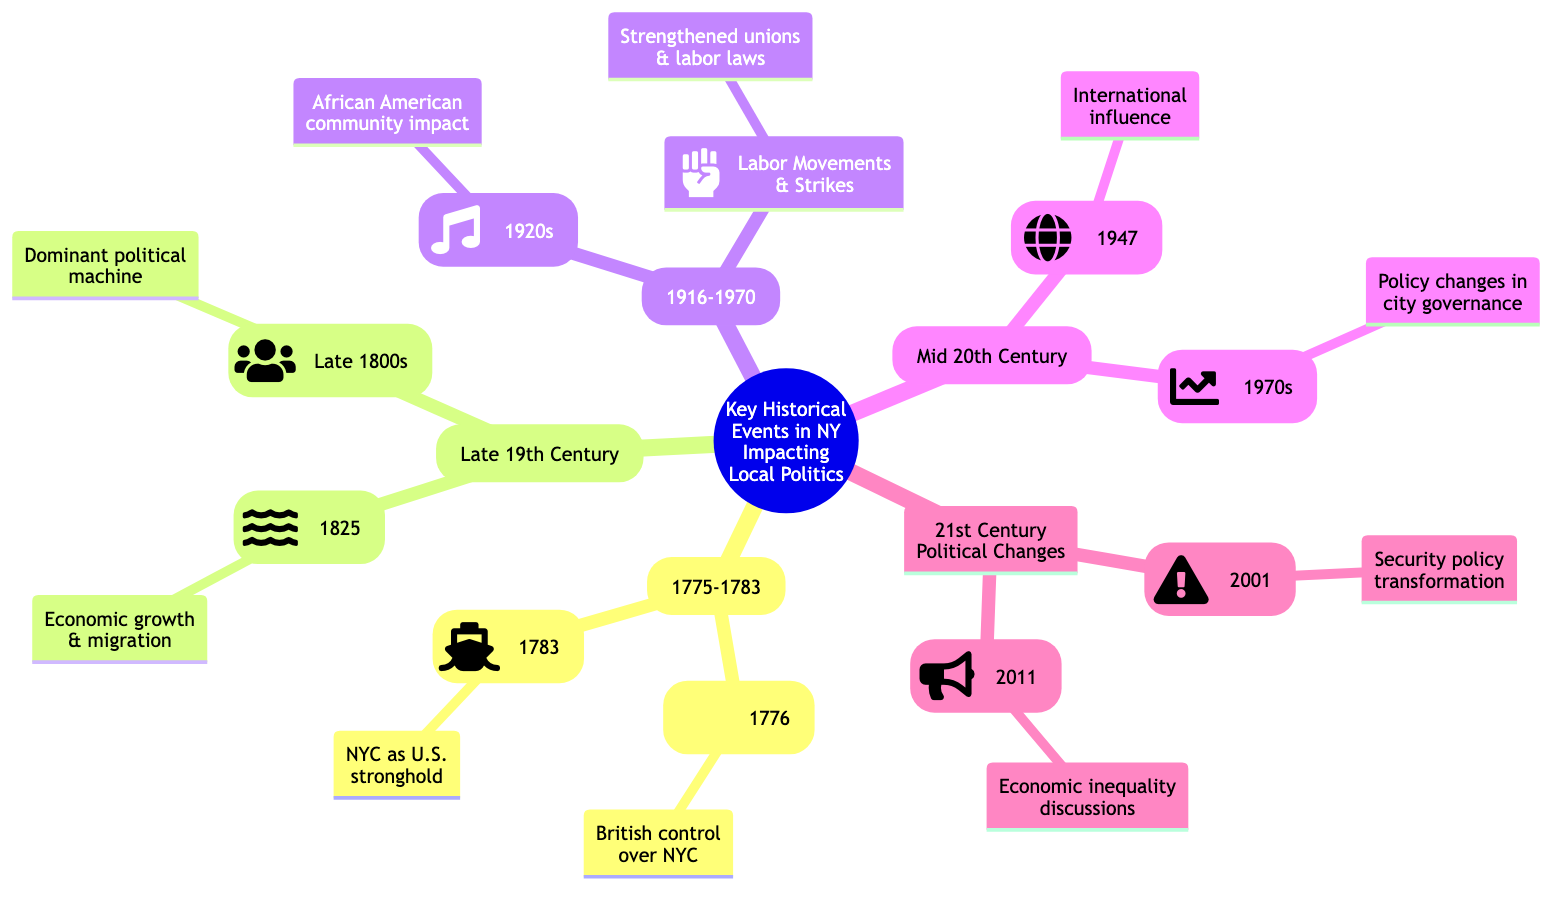What significant battle occurred during the Revolutionary War in 1776? The diagram states that the "Battle of Long Island" occurred in 1776 during the Revolutionary War, identifying it as a significant event within that time frame.
Answer: Battle of Long Island What year did the British leave New York City? The diagram notes "Evacuation Day" took place in 1783, marking the year the British troops left New York City.
Answer: 1783 How many main historical periods are highlighted in the diagram? By counting the different primary nodes labeled as historical periods, we find there are five main periods: Revolutionary War, Industrialization Era, Great Migration, Post-War Era, and 21st Century Political Changes.
Answer: 5 What impact did the completion of the Erie Canal have? The diagram indicates that the completion of the Erie Canal in 1825 "Facilitated economic growth and migration, altered political landscape," summarizing its significant impact on local politics.
Answer: Economic growth and migration Which event marked the construction of the United Nations Headquarters? The node for "Construction of the United Nations Headquarters" denotes that this event took place in 1947, providing a specific year linked to this significant occurrence in the context of New York's political influence.
Answer: 1947 What movement in the 1920s significantly influenced the African American community in NYC? The diagram highlights the "Harlem Renaissance" as a cultural movement impacting the African American community in NYC during the 1920s, indicating its significance in this area.
Answer: Harlem Renaissance Which event transformed security policies in New York City? According to the diagram, the "September 11 Attacks" in 2001 are indicated as the event that transformed security policies and the political focus in NYC, establishing a direct connection between the event and its impact.
Answer: September 11 Attacks What political machine rose to prominence in the late 1800s? The "Rise of Tammany Hall" is specified in the diagram as the political machine that became dominant in influencing local politics during the late 1800s, specifying its significance in this context.
Answer: Tammany Hall What social movement in 2011 galvanized discussions on economic inequality? The diagram identifies "Occupy Wall Street" (2011) as the event that galvanized discussions on economic inequality, directly linking it to its political influence in both local and national politics.
Answer: Occupy Wall Street What crisis in the 1970s led to policy changes in city governance? The diagram mentions the "Economic Crisis of the 1970s" as the event that led to financial bailouts and significant policy changes in city governance, establishing the connection between the crisis and its implications for governance.
Answer: Economic Crisis of the 1970s 